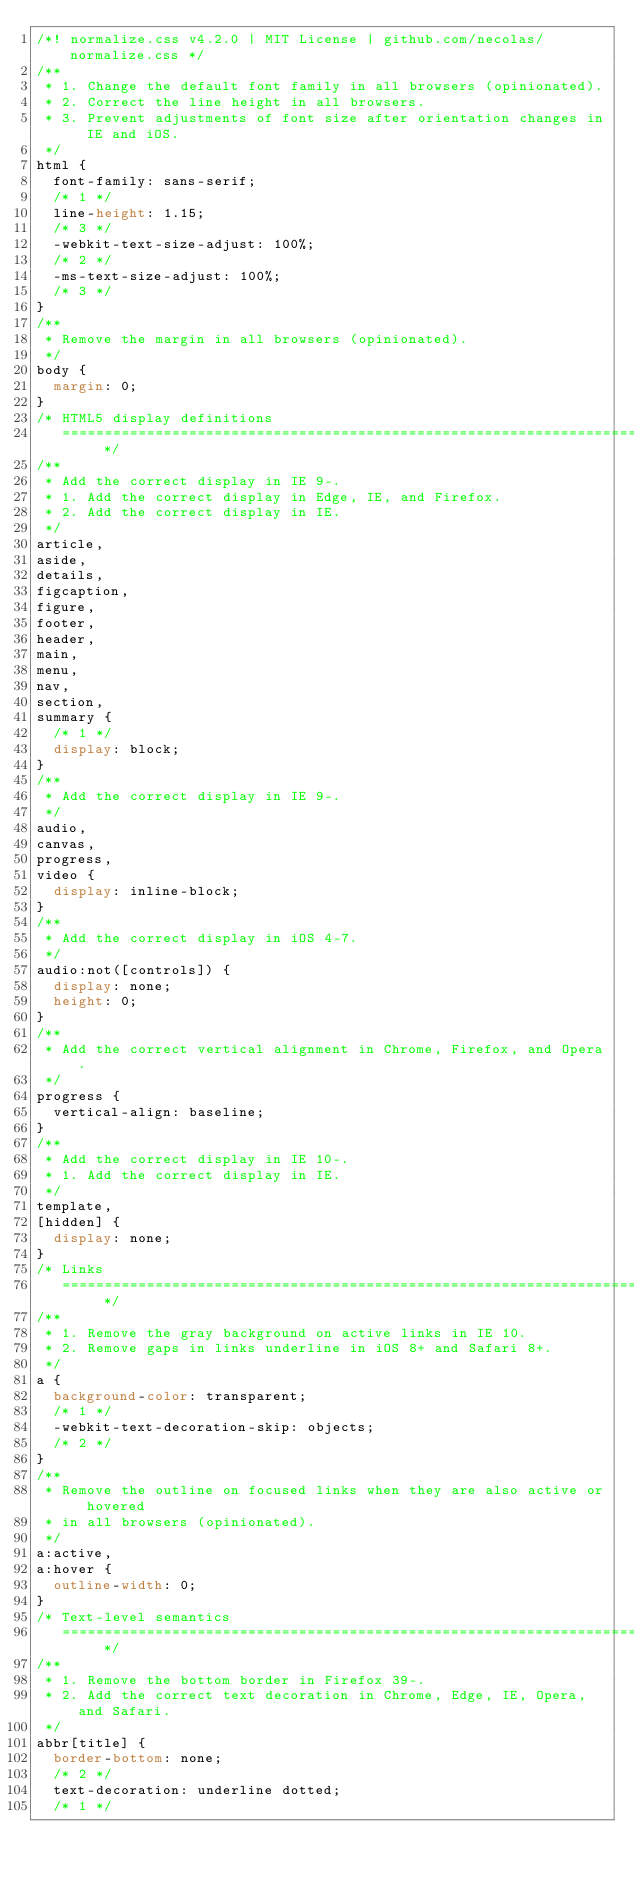Convert code to text. <code><loc_0><loc_0><loc_500><loc_500><_CSS_>/*! normalize.css v4.2.0 | MIT License | github.com/necolas/normalize.css */
/**
 * 1. Change the default font family in all browsers (opinionated).
 * 2. Correct the line height in all browsers.
 * 3. Prevent adjustments of font size after orientation changes in IE and iOS.
 */
html {
  font-family: sans-serif;
  /* 1 */
  line-height: 1.15;
  /* 3 */
  -webkit-text-size-adjust: 100%;
  /* 2 */
  -ms-text-size-adjust: 100%;
  /* 3 */
}
/**
 * Remove the margin in all browsers (opinionated).
 */
body {
  margin: 0;
}
/* HTML5 display definitions
   ========================================================================== */
/**
 * Add the correct display in IE 9-.
 * 1. Add the correct display in Edge, IE, and Firefox.
 * 2. Add the correct display in IE.
 */
article,
aside,
details,
figcaption,
figure,
footer,
header,
main,
menu,
nav,
section,
summary {
  /* 1 */
  display: block;
}
/**
 * Add the correct display in IE 9-.
 */
audio,
canvas,
progress,
video {
  display: inline-block;
}
/**
 * Add the correct display in iOS 4-7.
 */
audio:not([controls]) {
  display: none;
  height: 0;
}
/**
 * Add the correct vertical alignment in Chrome, Firefox, and Opera.
 */
progress {
  vertical-align: baseline;
}
/**
 * Add the correct display in IE 10-.
 * 1. Add the correct display in IE.
 */
template,
[hidden] {
  display: none;
}
/* Links
   ========================================================================== */
/**
 * 1. Remove the gray background on active links in IE 10.
 * 2. Remove gaps in links underline in iOS 8+ and Safari 8+.
 */
a {
  background-color: transparent;
  /* 1 */
  -webkit-text-decoration-skip: objects;
  /* 2 */
}
/**
 * Remove the outline on focused links when they are also active or hovered
 * in all browsers (opinionated).
 */
a:active,
a:hover {
  outline-width: 0;
}
/* Text-level semantics
   ========================================================================== */
/**
 * 1. Remove the bottom border in Firefox 39-.
 * 2. Add the correct text decoration in Chrome, Edge, IE, Opera, and Safari.
 */
abbr[title] {
  border-bottom: none;
  /* 2 */
  text-decoration: underline dotted;
  /* 1 */</code> 